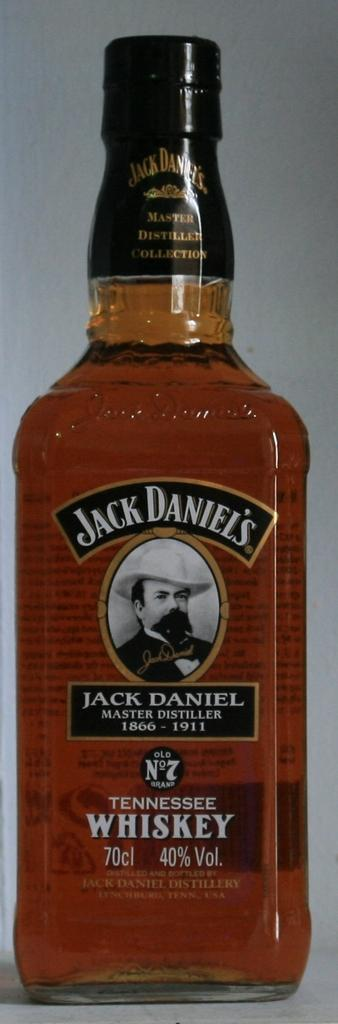<image>
Present a compact description of the photo's key features. A bottle of Jack Daniel's Tennessee Whiskey which consists of 40% alcohol. 